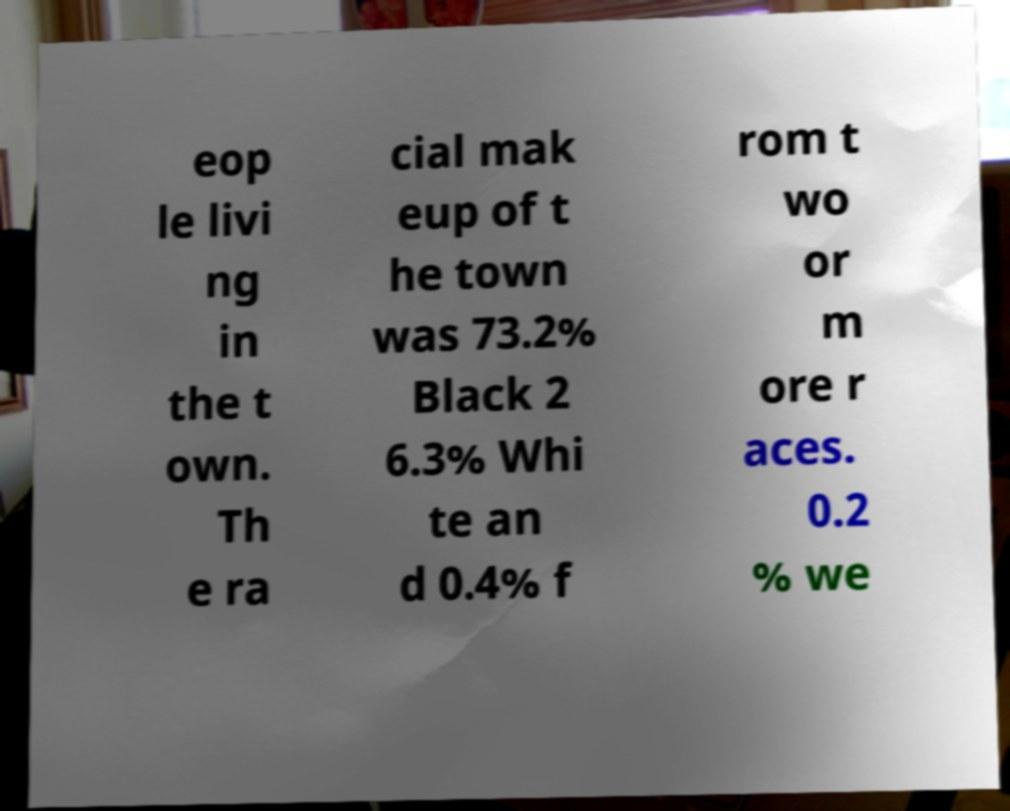Please identify and transcribe the text found in this image. eop le livi ng in the t own. Th e ra cial mak eup of t he town was 73.2% Black 2 6.3% Whi te an d 0.4% f rom t wo or m ore r aces. 0.2 % we 